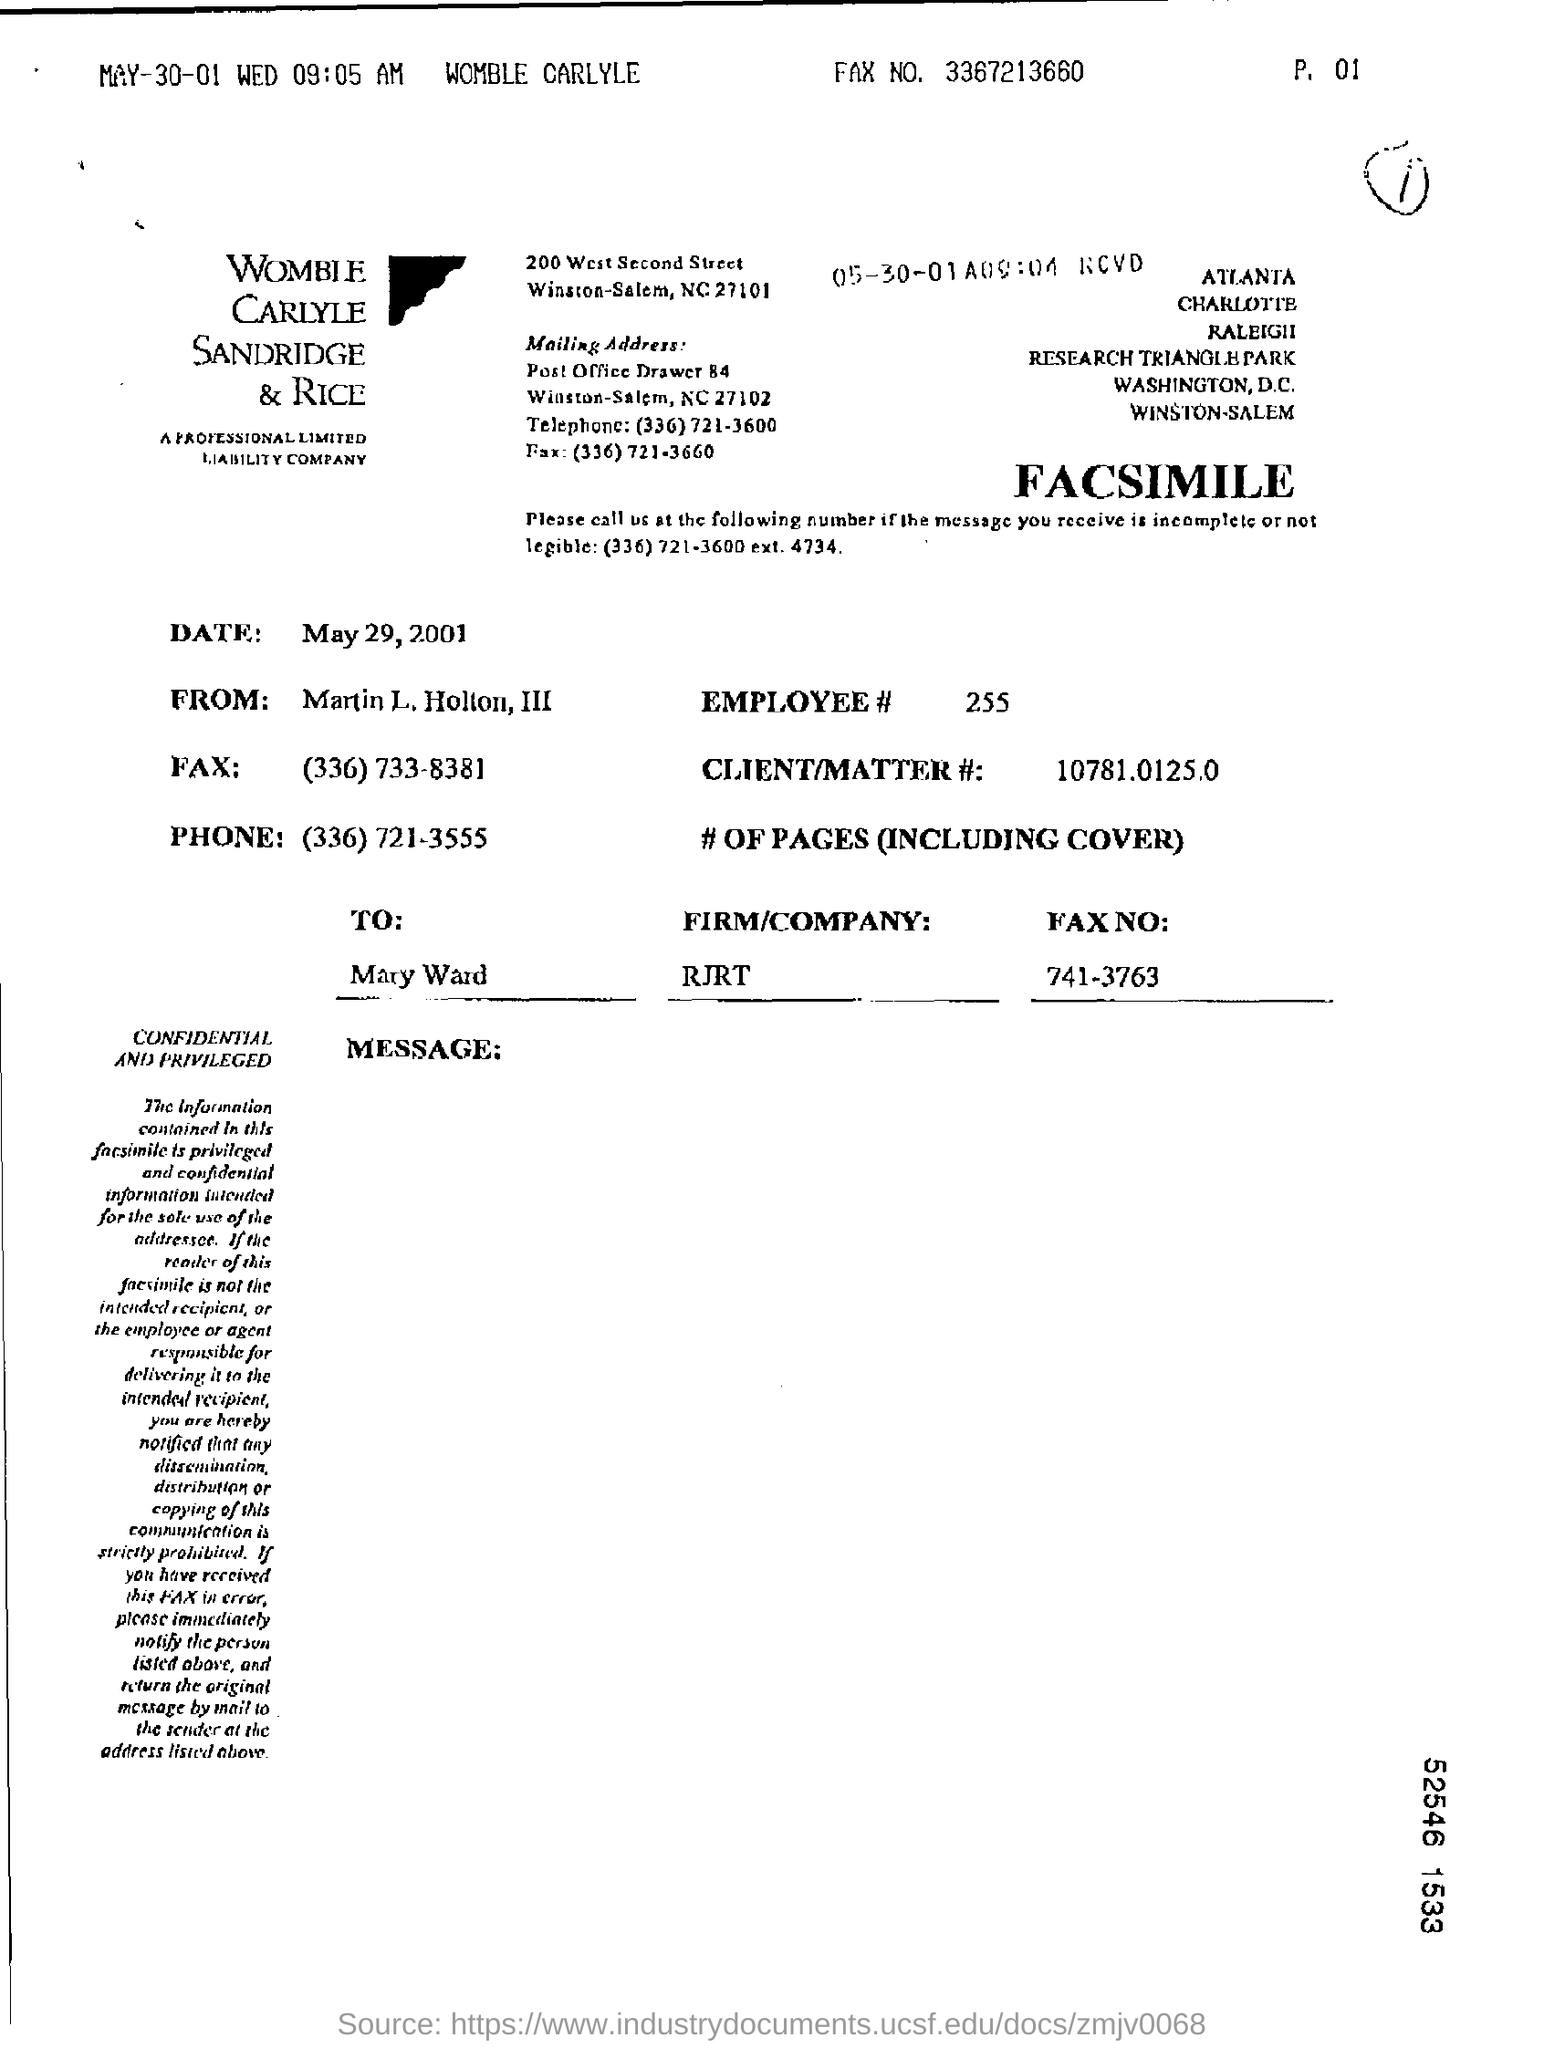Specify some key components in this picture. The letter is addressed to Mary Ward. The Client/Matter number is 10781.0125.0 The employee number is 255. 